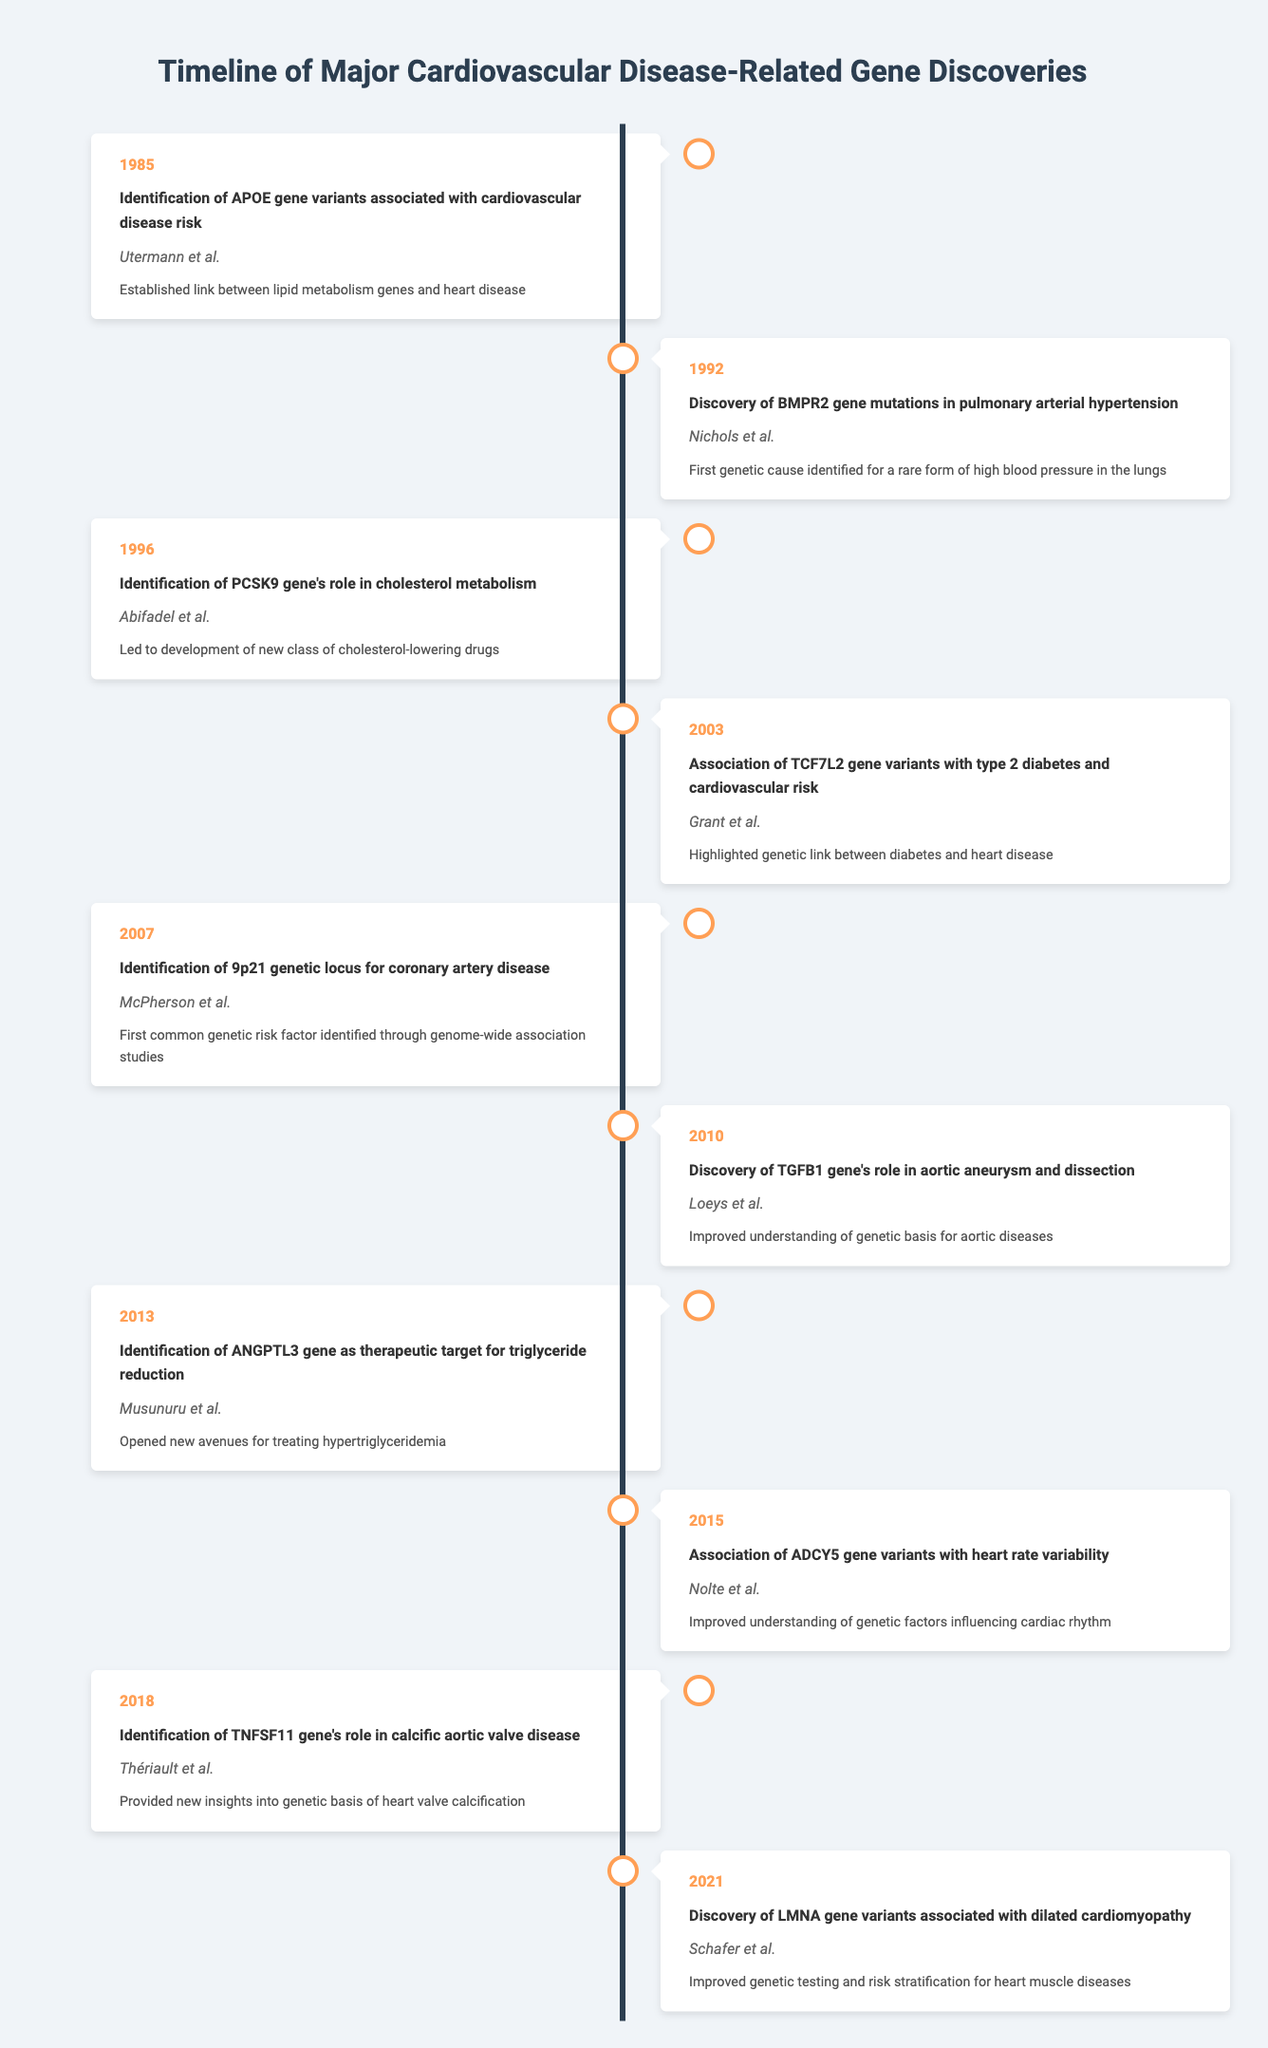What significant link was established in 1985? The table indicates that in 1985, the identification of APOE gene variants associated with cardiovascular disease risk established a significant link between lipid metabolism genes and heart disease.
Answer: Link between lipid metabolism genes and heart disease Which gene's role in cholesterol metabolism was identified in 1996? According to the table, the PCSK9 gene's role in cholesterol metabolism was identified in 1996, leading to new developments in cholesterol-lowering drugs.
Answer: PCSK9 How many years separate the discovery of BMPR2 gene mutations and the identification of the 9p21 genetic locus? The discovery of BMPR2 gene mutations was in 1992, and the identification of the 9p21 genetic locus occurred in 2007. The difference in years is 2007 - 1992 = 15 years.
Answer: 15 years Is there a gene associated with heart valve calcification discovered in 2018? Yes, the TNFSF11 gene's role in calcific aortic valve disease was identified in 2018, indicating a genetic link to heart valve calcification.
Answer: Yes Which researcher is associated with the discovery of LMNA gene variants in 2021? The table shows that the discovery of LMNA gene variants associated with dilated cardiomyopathy in 2021 was conducted by Schafer et al.
Answer: Schafer et al What is the significance of the discovery made by Grant et al. in 2003? The table states that the association of TCF7L2 gene variants with type 2 diabetes and cardiovascular risk highlighted a genetic link between diabetes and heart disease, which emphasizes its significance.
Answer: Highlighted genetic link between diabetes and heart disease How many total discoveries are reported in this timeline? The timeline lists a total of 10 discoveries from 1985 to 2021, providing an overview of significant genetic findings related to cardiovascular diseases.
Answer: 10 Which discovery provided new insights into cardiac rhythm in 2015? The table indicates that in 2015, the association of ADCY5 gene variants with heart rate variability improved the understanding of genetic factors influencing cardiac rhythm.
Answer: Association of ADCY5 gene variants Have any of the discoveries been related to aortic diseases? Yes, the discovery of the TGFB1 gene's role in aortic aneurysm and dissection in 2010 indicates a genetic basis for aortic diseases.
Answer: Yes What was the significance of the identification of ANGPTL3 in 2013? The table describes that the identification of ANGPTL3 as a therapeutic target for triglyceride reduction opened new avenues for treating hypertriglyceridemia, marking its significance.
Answer: Opened new avenues for treating hypertriglyceridemia 